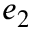Convert formula to latex. <formula><loc_0><loc_0><loc_500><loc_500>e _ { 2 }</formula> 